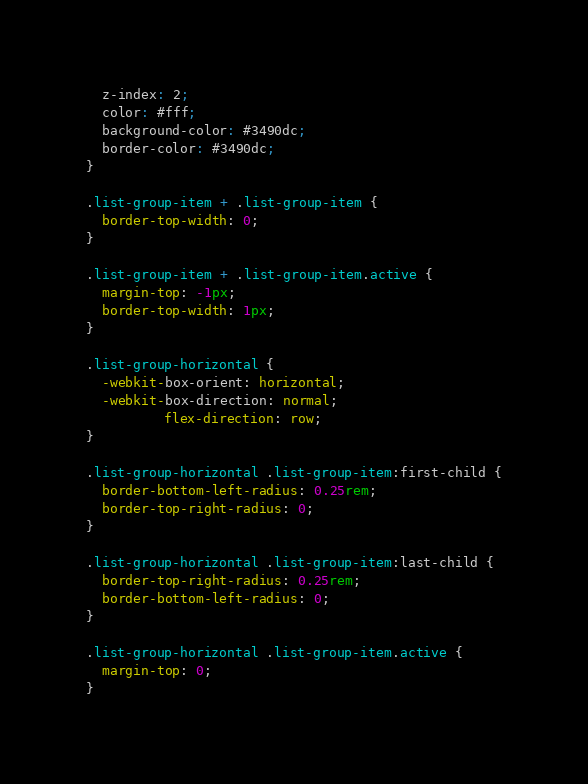Convert code to text. <code><loc_0><loc_0><loc_500><loc_500><_CSS_>  z-index: 2;
  color: #fff;
  background-color: #3490dc;
  border-color: #3490dc;
}

.list-group-item + .list-group-item {
  border-top-width: 0;
}

.list-group-item + .list-group-item.active {
  margin-top: -1px;
  border-top-width: 1px;
}

.list-group-horizontal {
  -webkit-box-orient: horizontal;
  -webkit-box-direction: normal;
          flex-direction: row;
}

.list-group-horizontal .list-group-item:first-child {
  border-bottom-left-radius: 0.25rem;
  border-top-right-radius: 0;
}

.list-group-horizontal .list-group-item:last-child {
  border-top-right-radius: 0.25rem;
  border-bottom-left-radius: 0;
}

.list-group-horizontal .list-group-item.active {
  margin-top: 0;
}
</code> 